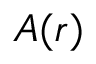Convert formula to latex. <formula><loc_0><loc_0><loc_500><loc_500>A ( r )</formula> 